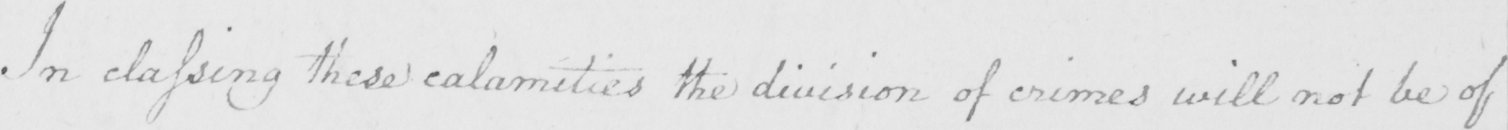What text is written in this handwritten line? In classing these calamities the division of crimes will not be of 